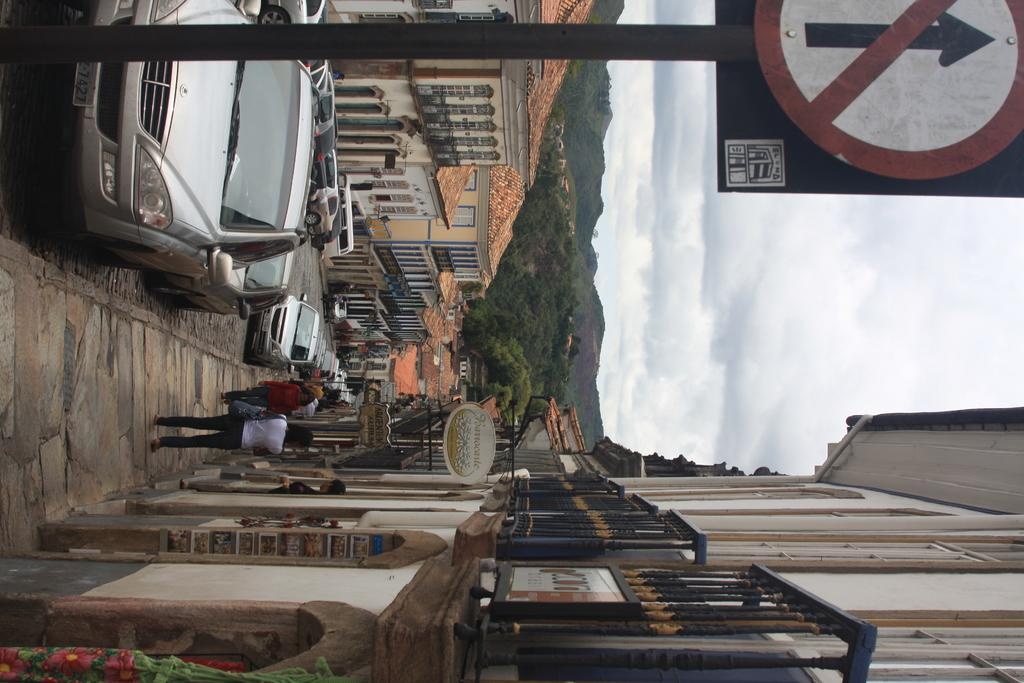What type of structures can be seen in the image? There are buildings in the image. What else is present in the image besides buildings? There are cars, people, a sign pole, trees, and the sky visible in the image. Can you describe the vehicles in the image? There are cars in the image. What is the sign pole used for in the image? The sign pole is likely used for displaying signs or advertisements. What type of vegetation is present in the image? There are trees in the image. Can you tell me how many pickles are hanging from the sign pole in the image? There are no pickles present in the image; the sign pole is likely used for displaying signs or advertisements. What type of snail can be seen crawling up the side of the building in the image? There are no snails visible in the image; the focus is on the buildings, cars, people, sign pole, trees, and sky. 